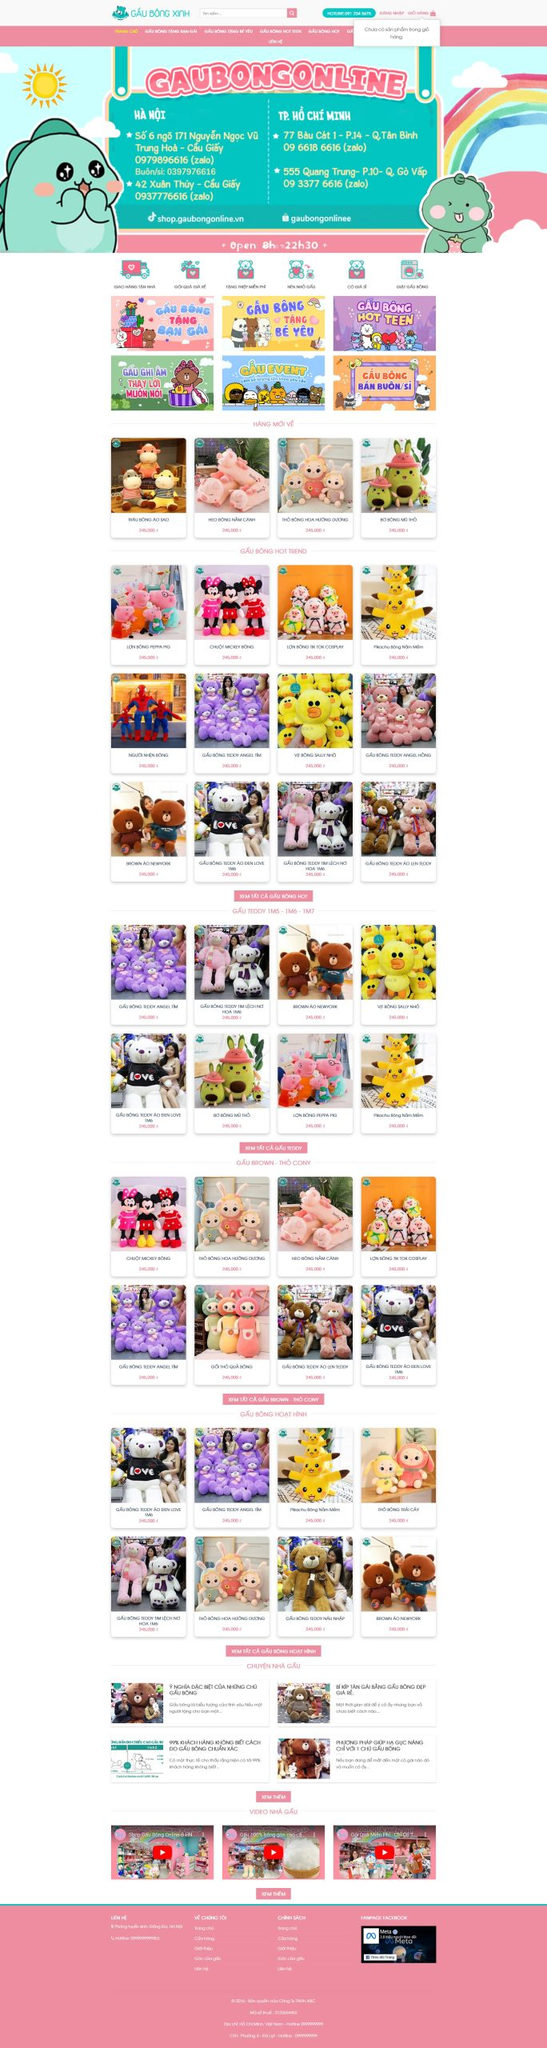Liệt kê 5 ngành nghề, lĩnh vực phù hợp với website này, phân cách các màu sắc bằng dấu phẩy. Chỉ trả về kết quả, phân cách bằng dấy phẩy
 Thú nhồi bông, Quà tặng, Đồ chơi trẻ em, Trang trí nội thất, Quà lưu niệm 